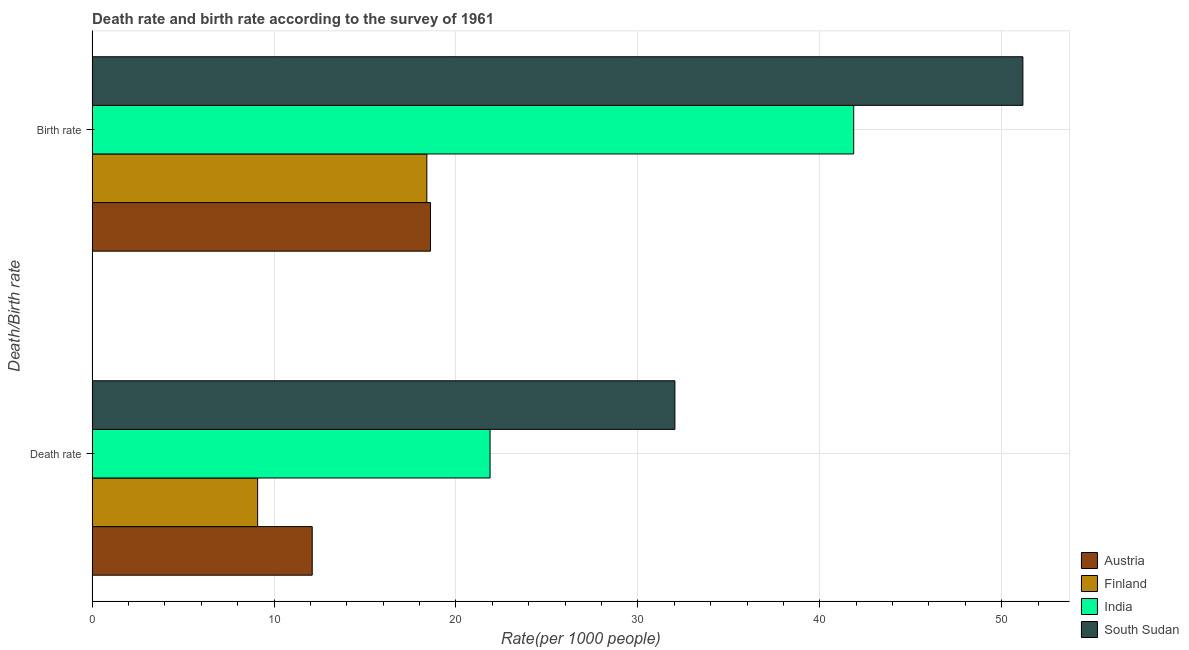How many different coloured bars are there?
Your answer should be compact. 4. How many groups of bars are there?
Ensure brevity in your answer.  2. Are the number of bars per tick equal to the number of legend labels?
Keep it short and to the point. Yes. Are the number of bars on each tick of the Y-axis equal?
Offer a terse response. Yes. How many bars are there on the 1st tick from the bottom?
Your answer should be compact. 4. What is the label of the 2nd group of bars from the top?
Keep it short and to the point. Death rate. What is the birth rate in South Sudan?
Keep it short and to the point. 51.16. Across all countries, what is the maximum death rate?
Provide a succinct answer. 32.04. In which country was the death rate maximum?
Provide a succinct answer. South Sudan. In which country was the birth rate minimum?
Ensure brevity in your answer.  Finland. What is the total death rate in the graph?
Give a very brief answer. 75.11. What is the difference between the birth rate in Austria and that in South Sudan?
Offer a terse response. -32.56. What is the difference between the death rate in Finland and the birth rate in South Sudan?
Your answer should be very brief. -42.06. What is the average birth rate per country?
Offer a terse response. 32.51. What is the difference between the birth rate and death rate in Austria?
Offer a very short reply. 6.5. In how many countries, is the death rate greater than 28 ?
Your answer should be compact. 1. What is the ratio of the death rate in India to that in Austria?
Offer a very short reply. 1.81. What does the 1st bar from the top in Birth rate represents?
Offer a very short reply. South Sudan. What does the 1st bar from the bottom in Birth rate represents?
Provide a succinct answer. Austria. How many countries are there in the graph?
Offer a very short reply. 4. Where does the legend appear in the graph?
Provide a short and direct response. Bottom right. How are the legend labels stacked?
Offer a very short reply. Vertical. What is the title of the graph?
Offer a very short reply. Death rate and birth rate according to the survey of 1961. Does "Niger" appear as one of the legend labels in the graph?
Your answer should be very brief. No. What is the label or title of the X-axis?
Ensure brevity in your answer.  Rate(per 1000 people). What is the label or title of the Y-axis?
Ensure brevity in your answer.  Death/Birth rate. What is the Rate(per 1000 people) of Austria in Death rate?
Provide a short and direct response. 12.1. What is the Rate(per 1000 people) in India in Death rate?
Keep it short and to the point. 21.88. What is the Rate(per 1000 people) of South Sudan in Death rate?
Your answer should be compact. 32.04. What is the Rate(per 1000 people) in Austria in Birth rate?
Make the answer very short. 18.6. What is the Rate(per 1000 people) of Finland in Birth rate?
Your response must be concise. 18.4. What is the Rate(per 1000 people) of India in Birth rate?
Your answer should be very brief. 41.87. What is the Rate(per 1000 people) of South Sudan in Birth rate?
Make the answer very short. 51.16. Across all Death/Birth rate, what is the maximum Rate(per 1000 people) of Finland?
Offer a terse response. 18.4. Across all Death/Birth rate, what is the maximum Rate(per 1000 people) in India?
Keep it short and to the point. 41.87. Across all Death/Birth rate, what is the maximum Rate(per 1000 people) of South Sudan?
Ensure brevity in your answer.  51.16. Across all Death/Birth rate, what is the minimum Rate(per 1000 people) of Finland?
Your response must be concise. 9.1. Across all Death/Birth rate, what is the minimum Rate(per 1000 people) in India?
Offer a terse response. 21.88. Across all Death/Birth rate, what is the minimum Rate(per 1000 people) in South Sudan?
Your response must be concise. 32.04. What is the total Rate(per 1000 people) of Austria in the graph?
Your answer should be compact. 30.7. What is the total Rate(per 1000 people) of Finland in the graph?
Your response must be concise. 27.5. What is the total Rate(per 1000 people) of India in the graph?
Keep it short and to the point. 63.74. What is the total Rate(per 1000 people) in South Sudan in the graph?
Offer a very short reply. 83.2. What is the difference between the Rate(per 1000 people) of Finland in Death rate and that in Birth rate?
Provide a short and direct response. -9.3. What is the difference between the Rate(per 1000 people) in India in Death rate and that in Birth rate?
Give a very brief answer. -19.99. What is the difference between the Rate(per 1000 people) of South Sudan in Death rate and that in Birth rate?
Provide a short and direct response. -19.13. What is the difference between the Rate(per 1000 people) of Austria in Death rate and the Rate(per 1000 people) of India in Birth rate?
Your response must be concise. -29.77. What is the difference between the Rate(per 1000 people) in Austria in Death rate and the Rate(per 1000 people) in South Sudan in Birth rate?
Give a very brief answer. -39.06. What is the difference between the Rate(per 1000 people) in Finland in Death rate and the Rate(per 1000 people) in India in Birth rate?
Your answer should be compact. -32.77. What is the difference between the Rate(per 1000 people) of Finland in Death rate and the Rate(per 1000 people) of South Sudan in Birth rate?
Offer a very short reply. -42.06. What is the difference between the Rate(per 1000 people) in India in Death rate and the Rate(per 1000 people) in South Sudan in Birth rate?
Your answer should be compact. -29.29. What is the average Rate(per 1000 people) of Austria per Death/Birth rate?
Ensure brevity in your answer.  15.35. What is the average Rate(per 1000 people) in Finland per Death/Birth rate?
Your answer should be very brief. 13.75. What is the average Rate(per 1000 people) of India per Death/Birth rate?
Your answer should be compact. 31.87. What is the average Rate(per 1000 people) in South Sudan per Death/Birth rate?
Your response must be concise. 41.6. What is the difference between the Rate(per 1000 people) in Austria and Rate(per 1000 people) in India in Death rate?
Your response must be concise. -9.78. What is the difference between the Rate(per 1000 people) in Austria and Rate(per 1000 people) in South Sudan in Death rate?
Keep it short and to the point. -19.94. What is the difference between the Rate(per 1000 people) of Finland and Rate(per 1000 people) of India in Death rate?
Your answer should be very brief. -12.78. What is the difference between the Rate(per 1000 people) in Finland and Rate(per 1000 people) in South Sudan in Death rate?
Your response must be concise. -22.94. What is the difference between the Rate(per 1000 people) in India and Rate(per 1000 people) in South Sudan in Death rate?
Give a very brief answer. -10.16. What is the difference between the Rate(per 1000 people) of Austria and Rate(per 1000 people) of Finland in Birth rate?
Keep it short and to the point. 0.2. What is the difference between the Rate(per 1000 people) of Austria and Rate(per 1000 people) of India in Birth rate?
Provide a succinct answer. -23.27. What is the difference between the Rate(per 1000 people) in Austria and Rate(per 1000 people) in South Sudan in Birth rate?
Your answer should be compact. -32.56. What is the difference between the Rate(per 1000 people) of Finland and Rate(per 1000 people) of India in Birth rate?
Make the answer very short. -23.46. What is the difference between the Rate(per 1000 people) in Finland and Rate(per 1000 people) in South Sudan in Birth rate?
Provide a short and direct response. -32.77. What is the difference between the Rate(per 1000 people) of India and Rate(per 1000 people) of South Sudan in Birth rate?
Provide a short and direct response. -9.3. What is the ratio of the Rate(per 1000 people) of Austria in Death rate to that in Birth rate?
Offer a very short reply. 0.65. What is the ratio of the Rate(per 1000 people) in Finland in Death rate to that in Birth rate?
Provide a succinct answer. 0.49. What is the ratio of the Rate(per 1000 people) of India in Death rate to that in Birth rate?
Provide a succinct answer. 0.52. What is the ratio of the Rate(per 1000 people) of South Sudan in Death rate to that in Birth rate?
Your response must be concise. 0.63. What is the difference between the highest and the second highest Rate(per 1000 people) in India?
Provide a short and direct response. 19.99. What is the difference between the highest and the second highest Rate(per 1000 people) in South Sudan?
Your answer should be compact. 19.13. What is the difference between the highest and the lowest Rate(per 1000 people) in Austria?
Your answer should be very brief. 6.5. What is the difference between the highest and the lowest Rate(per 1000 people) of India?
Offer a terse response. 19.99. What is the difference between the highest and the lowest Rate(per 1000 people) of South Sudan?
Make the answer very short. 19.13. 